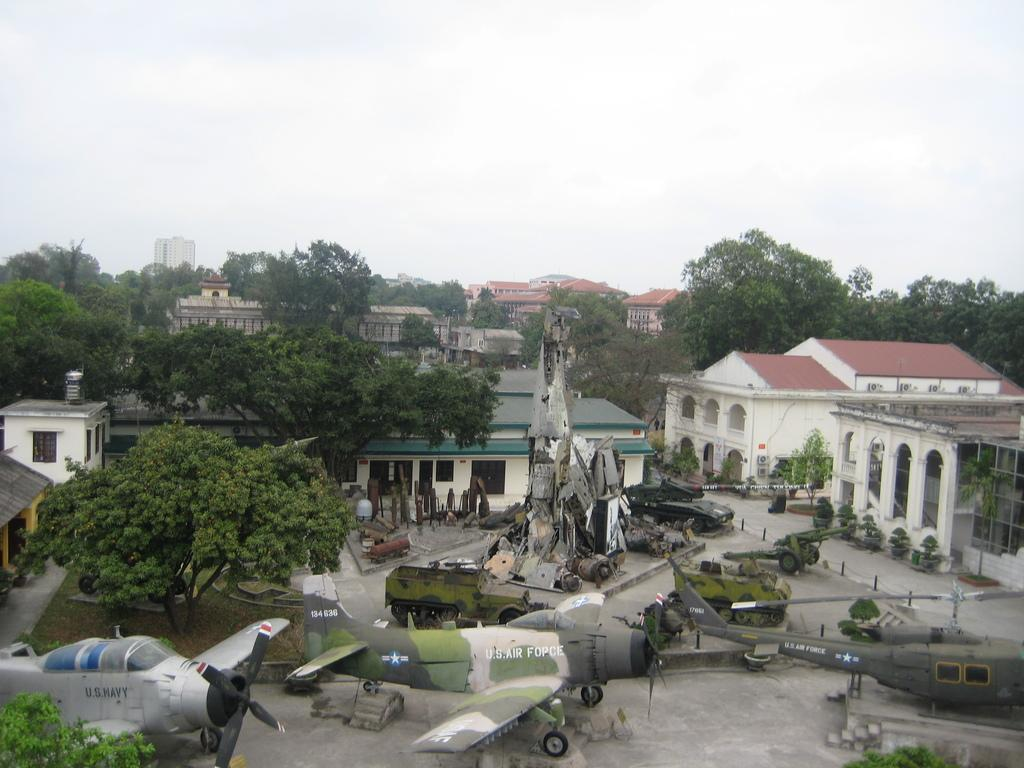How many aeroplanes are in the image? There are three aeroplanes in the image. Where are the aeroplanes located in the image? The aeroplanes are at the bottom of the image. What else can be seen in the image besides the aeroplanes? There are trees and big houses in the image. Where are the trees located in relation to the aeroplanes? The trees are located below the aeroplanes. Where are the big houses located in relation to the trees? The houses are located near the trees. What is visible at the top of the image? The sky is visible at the top of the image. What type of potato is being grown in the image? There is no potato present in the image. Can you describe the beetle that is crawling on the aeroplane in the image? There is no beetle present on the aeroplanes in the image. 